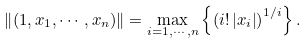Convert formula to latex. <formula><loc_0><loc_0><loc_500><loc_500>\left \| ( 1 , x _ { 1 } , \cdots , x _ { n } ) \right \| = \max _ { i = 1 , \cdots , n } \left \{ \left ( i ! \left | x _ { i } \right | \right ) ^ { 1 / i } \right \} .</formula> 